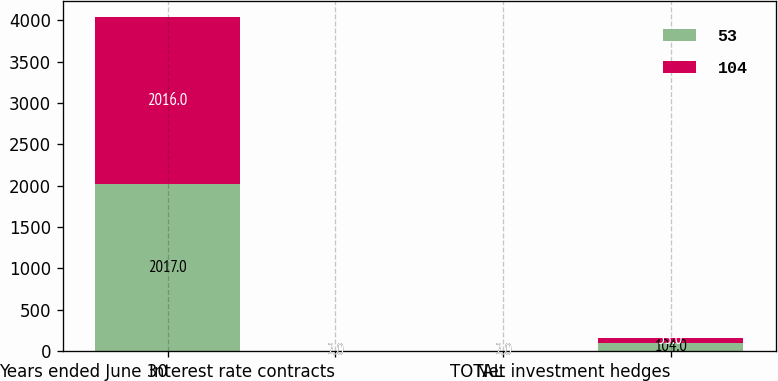Convert chart. <chart><loc_0><loc_0><loc_500><loc_500><stacked_bar_chart><ecel><fcel>Years ended June 30<fcel>Interest rate contracts<fcel>TOTAL<fcel>Net investment hedges<nl><fcel>53<fcel>2017<fcel>2<fcel>2<fcel>104<nl><fcel>104<fcel>2016<fcel>2<fcel>2<fcel>53<nl></chart> 